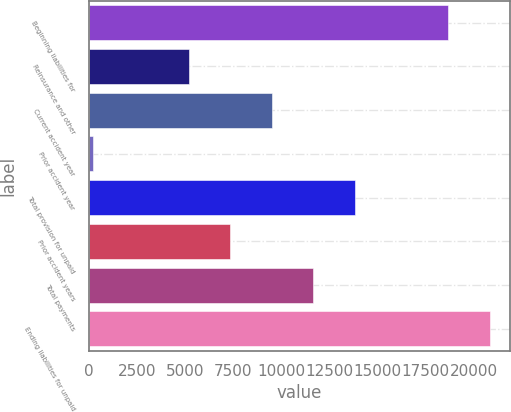Convert chart. <chart><loc_0><loc_0><loc_500><loc_500><bar_chart><fcel>Beginning liabilities for<fcel>Reinsurance and other<fcel>Current accident year<fcel>Prior accident year<fcel>Total provision for unpaid<fcel>Prior accident years<fcel>Total payments<fcel>Ending liabilities for unpaid<nl><fcel>18676<fcel>5185.8<fcel>9501.4<fcel>228<fcel>13817<fcel>7343.6<fcel>11659.2<fcel>20833.8<nl></chart> 